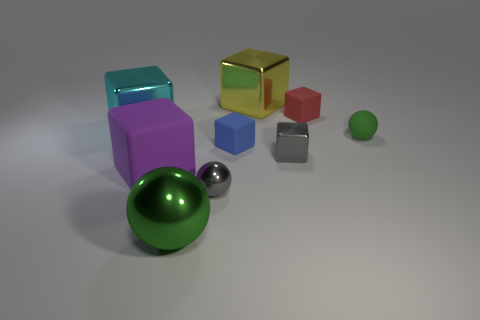Does the object on the right side of the small red object have the same color as the large metal object in front of the small green rubber thing?
Offer a very short reply. Yes. There is a cyan metal thing behind the large green shiny object; is its size the same as the green sphere behind the big purple rubber cube?
Keep it short and to the point. No. There is a sphere that is to the right of the gray shiny ball; are there any big green balls in front of it?
Your answer should be very brief. Yes. There is a tiny red rubber object; how many rubber objects are on the right side of it?
Provide a succinct answer. 1. What number of other things are the same color as the big sphere?
Offer a terse response. 1. Is the number of matte objects to the right of the small blue thing less than the number of cubes behind the purple matte object?
Provide a succinct answer. Yes. How many things are green balls that are behind the large green shiny sphere or big objects?
Your answer should be compact. 5. Does the gray cube have the same size as the rubber thing that is behind the small green object?
Give a very brief answer. Yes. What is the size of the purple object that is the same shape as the big cyan shiny object?
Give a very brief answer. Large. How many gray shiny things are to the left of the metal thing that is to the right of the large object that is behind the red matte block?
Give a very brief answer. 1. 